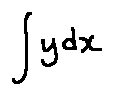<formula> <loc_0><loc_0><loc_500><loc_500>\int y d x</formula> 